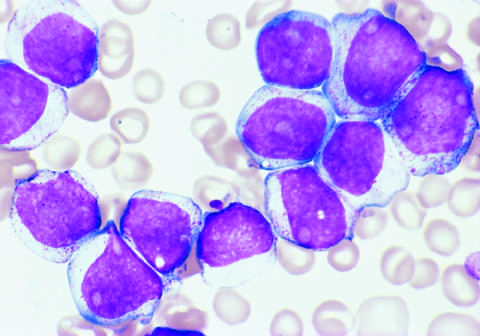what are positive for the stem cell marker cd34 and the myeloid lineage specific markers cd33 and cd15 subset?
Answer the question using a single word or phrase. The tumor cells 